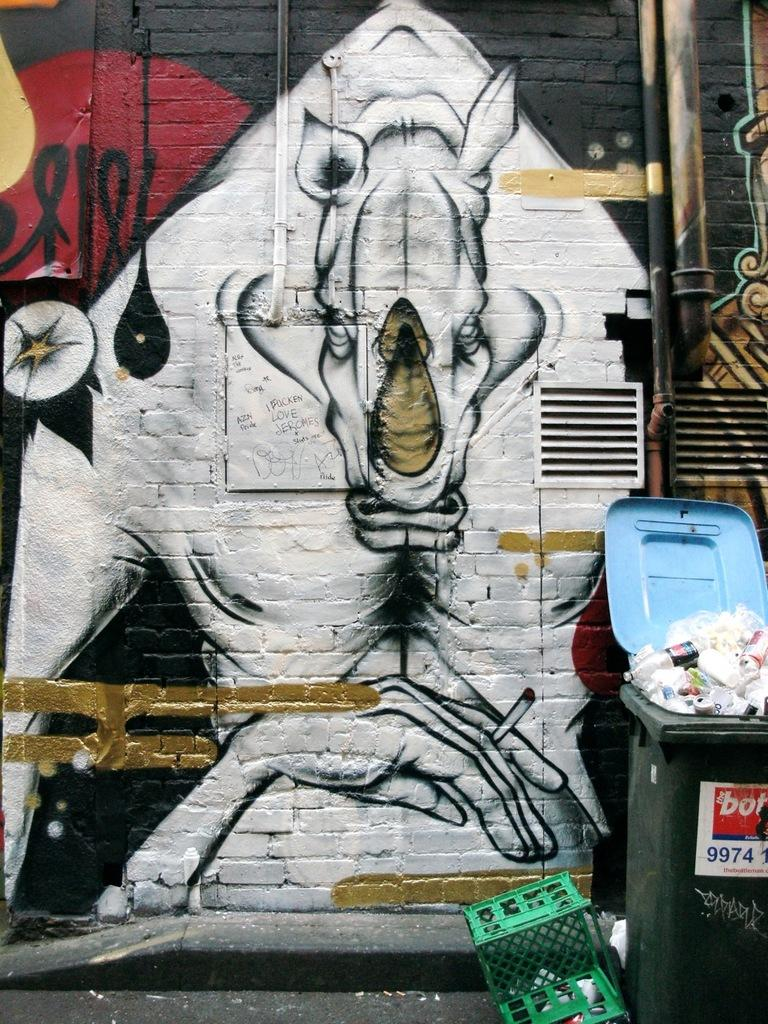<image>
Write a terse but informative summary of the picture. A trash can with the numbers 9974 is placed in front of a wall with graffiti 